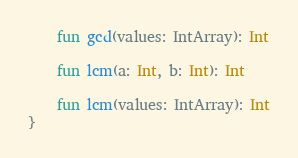<code> <loc_0><loc_0><loc_500><loc_500><_Kotlin_>
    fun gcd(values: IntArray): Int

    fun lcm(a: Int, b: Int): Int

    fun lcm(values: IntArray): Int
}
</code> 